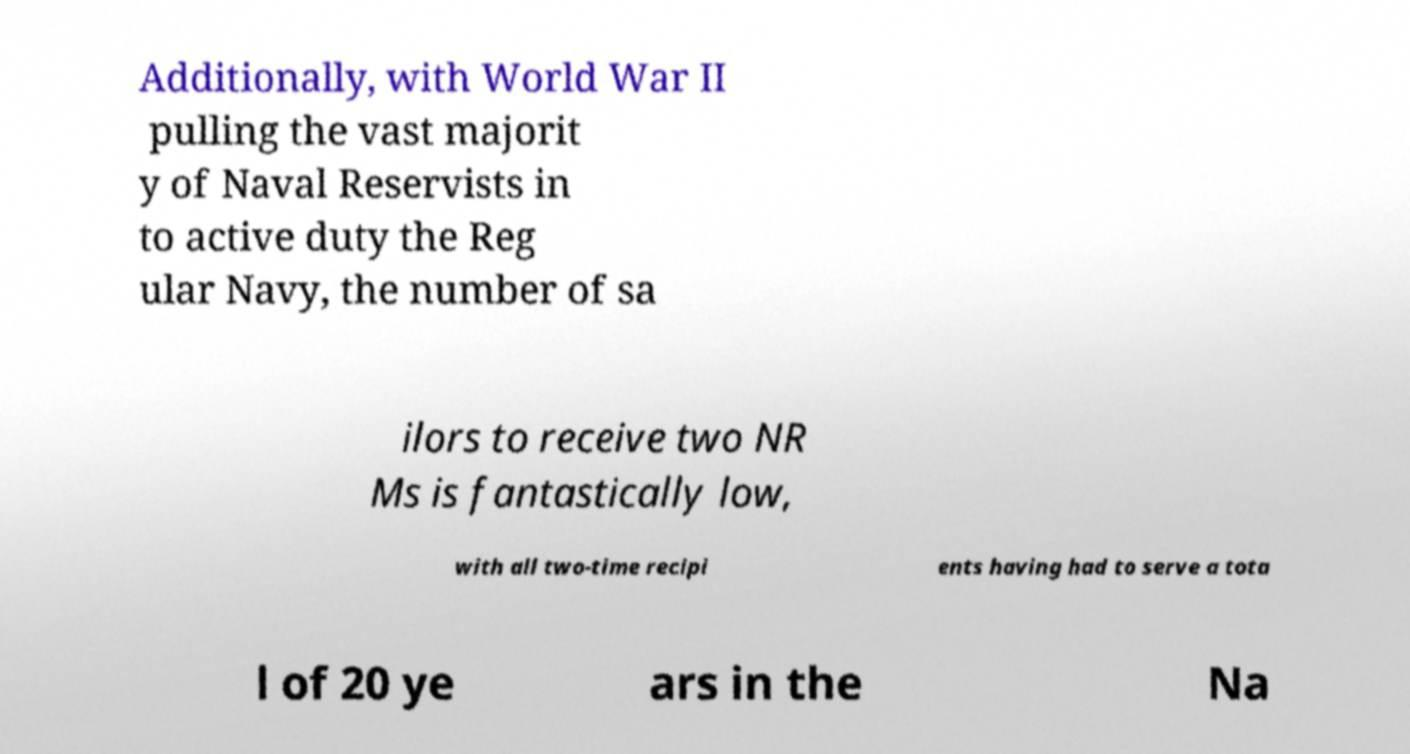Please identify and transcribe the text found in this image. Additionally, with World War II pulling the vast majorit y of Naval Reservists in to active duty the Reg ular Navy, the number of sa ilors to receive two NR Ms is fantastically low, with all two-time recipi ents having had to serve a tota l of 20 ye ars in the Na 